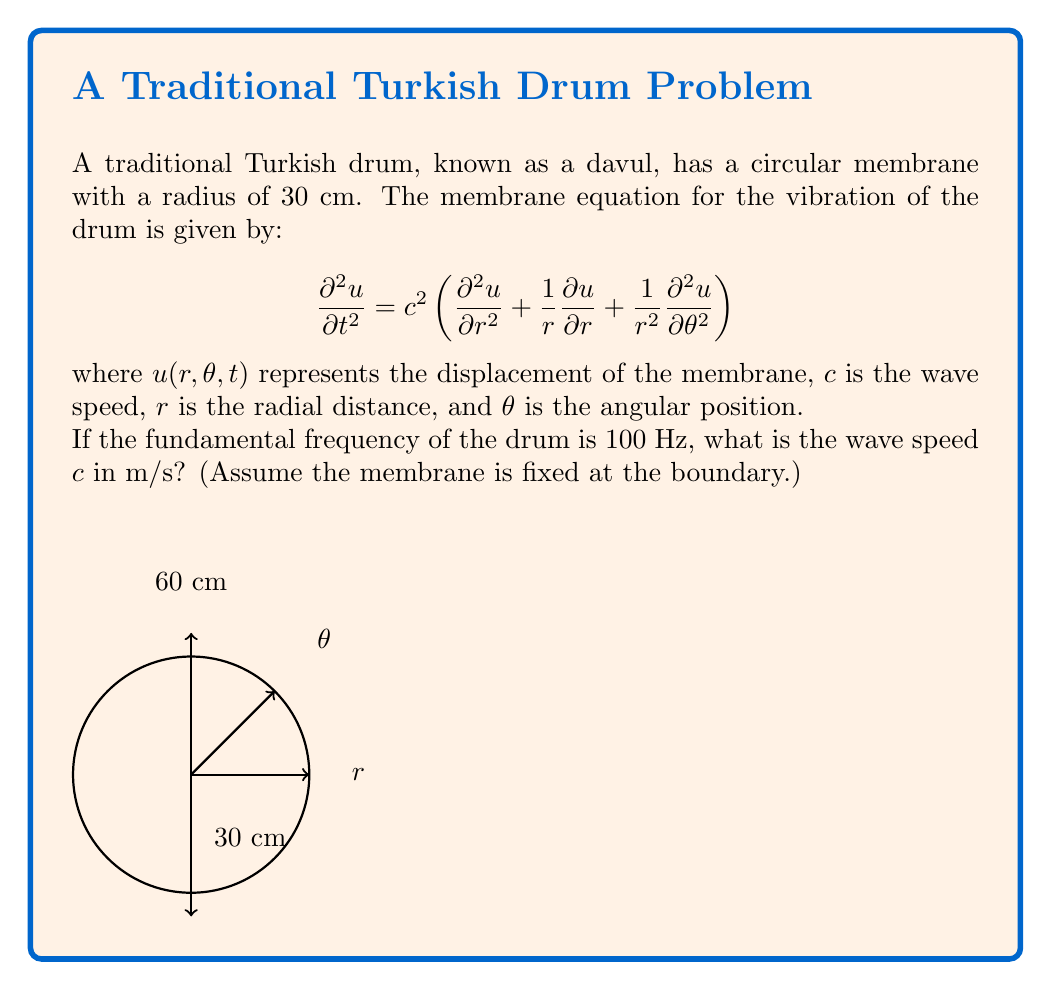Solve this math problem. Let's approach this step-by-step:

1) For a circular membrane fixed at the boundary, the fundamental mode of vibration corresponds to the first zero of the Bessel function of the first kind, $J_0(x)$. This zero occurs at $x \approx 2.4048$.

2) The relationship between the wave number $k$, radius $R$, and the first zero of $J_0(x)$ is:

   $$kR = 2.4048$$

3) The wave number $k$ is related to the angular frequency $\omega$ and wave speed $c$ by:

   $$k = \frac{\omega}{c}$$

4) The angular frequency $\omega$ is related to the frequency $f$ by:

   $$\omega = 2\pi f$$

5) Substituting these relations into the equation from step 2:

   $$\frac{\omega R}{c} = 2.4048$$

6) Rearranging to solve for $c$:

   $$c = \frac{\omega R}{2.4048} = \frac{2\pi f R}{2.4048}$$

7) Now, let's plug in our known values:
   - $f = 100$ Hz
   - $R = 30$ cm $= 0.3$ m

   $$c = \frac{2\pi (100)(0.3)}{2.4048} \approx 78.54 \text{ m/s}$$

Therefore, the wave speed $c$ is approximately 78.54 m/s.
Answer: $c \approx 78.54 \text{ m/s}$ 